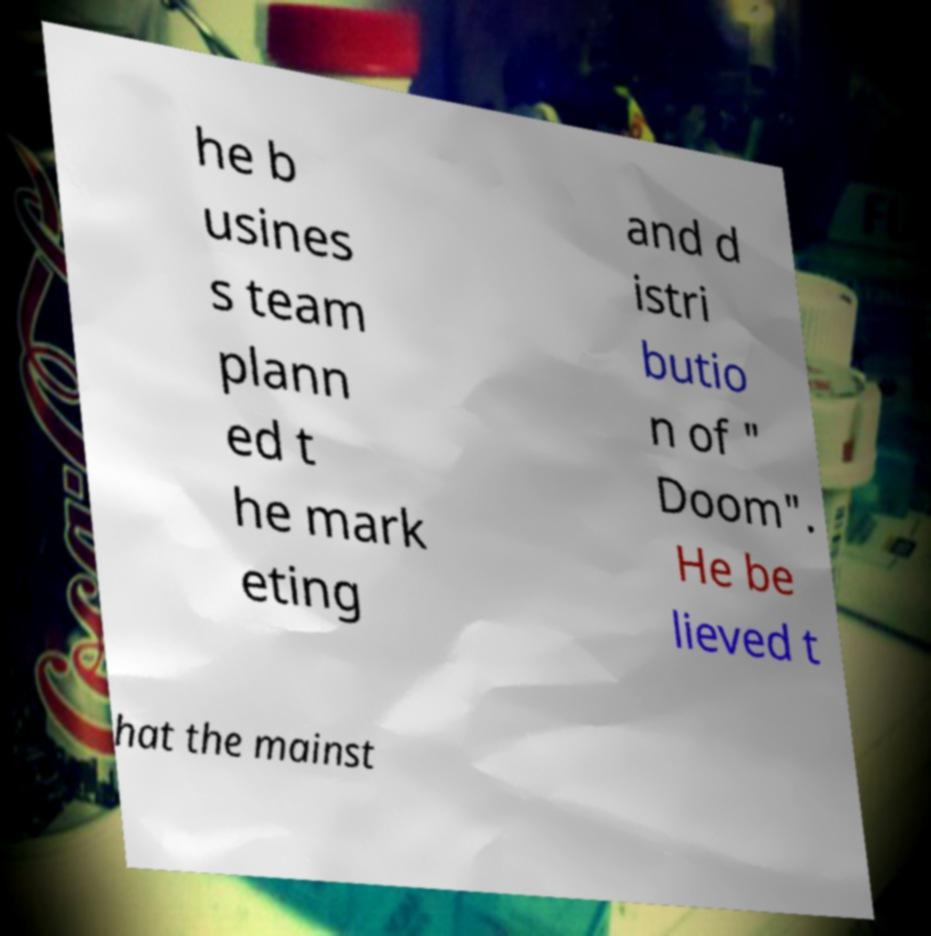Could you extract and type out the text from this image? he b usines s team plann ed t he mark eting and d istri butio n of " Doom". He be lieved t hat the mainst 